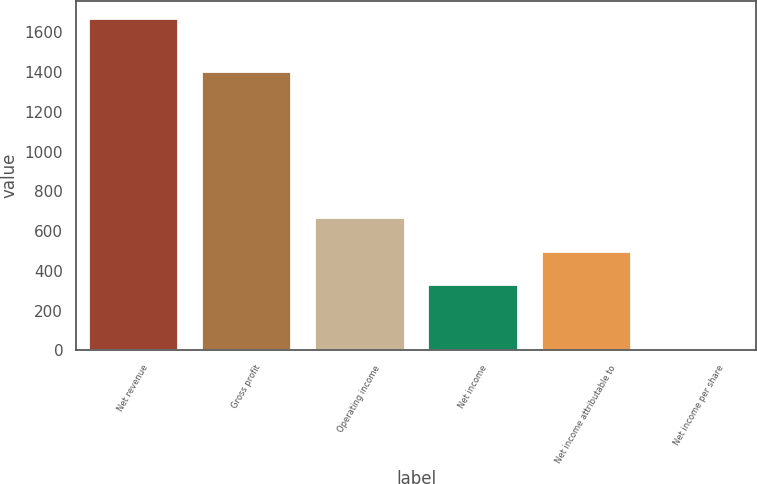Convert chart to OTSL. <chart><loc_0><loc_0><loc_500><loc_500><bar_chart><fcel>Net revenue<fcel>Gross profit<fcel>Operating income<fcel>Net income<fcel>Net income attributable to<fcel>Net income per share<nl><fcel>1673<fcel>1403<fcel>669.34<fcel>334.78<fcel>502.06<fcel>0.22<nl></chart> 